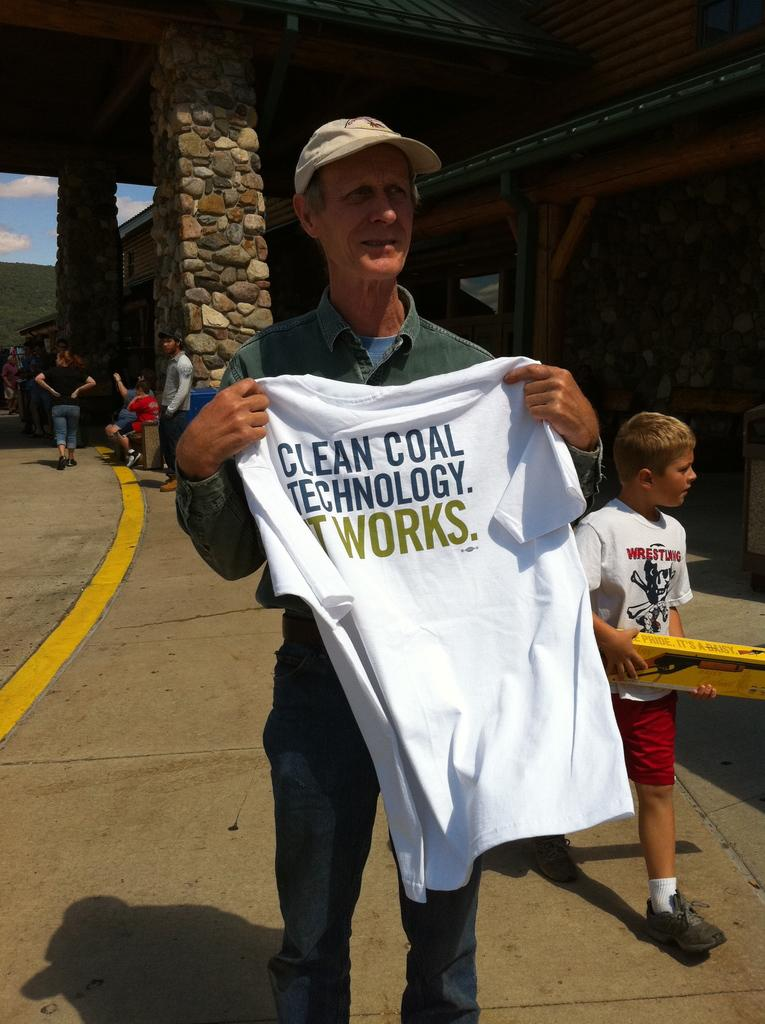<image>
Provide a brief description of the given image. Man holding a white shirt that says "It Works.". 